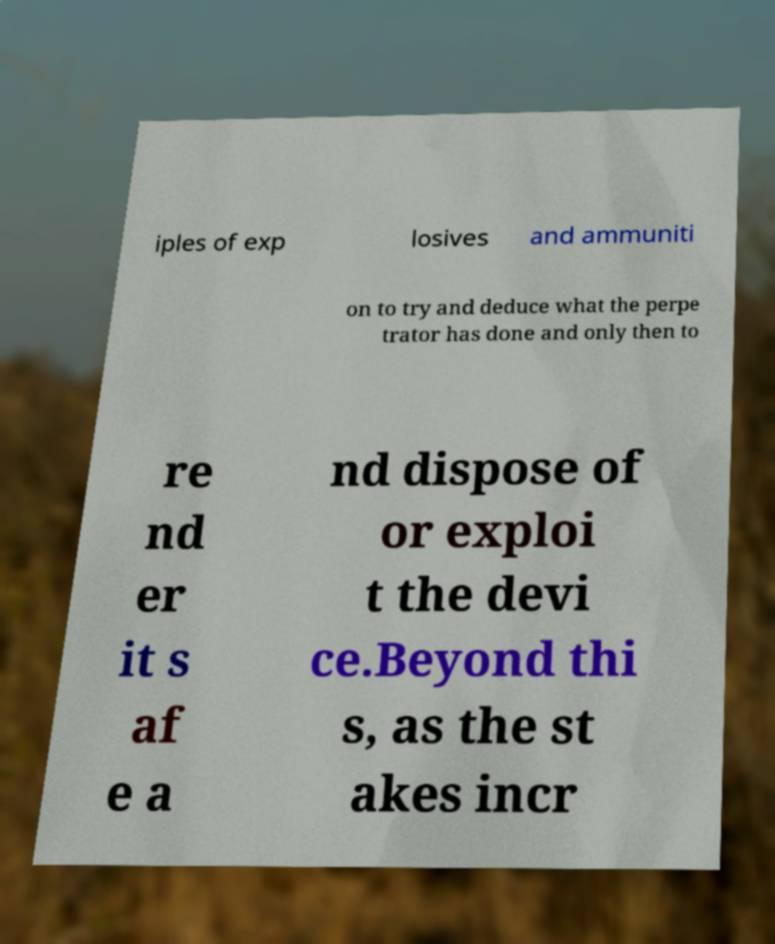Could you assist in decoding the text presented in this image and type it out clearly? iples of exp losives and ammuniti on to try and deduce what the perpe trator has done and only then to re nd er it s af e a nd dispose of or exploi t the devi ce.Beyond thi s, as the st akes incr 